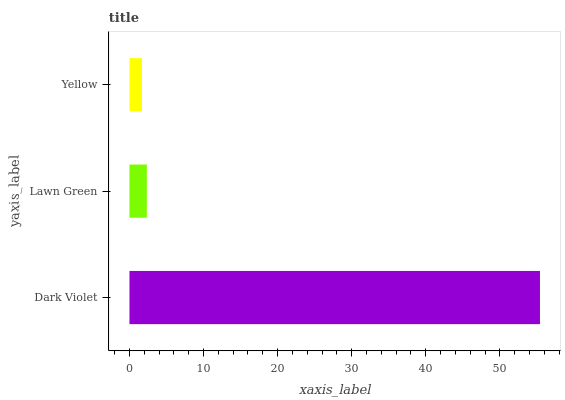Is Yellow the minimum?
Answer yes or no. Yes. Is Dark Violet the maximum?
Answer yes or no. Yes. Is Lawn Green the minimum?
Answer yes or no. No. Is Lawn Green the maximum?
Answer yes or no. No. Is Dark Violet greater than Lawn Green?
Answer yes or no. Yes. Is Lawn Green less than Dark Violet?
Answer yes or no. Yes. Is Lawn Green greater than Dark Violet?
Answer yes or no. No. Is Dark Violet less than Lawn Green?
Answer yes or no. No. Is Lawn Green the high median?
Answer yes or no. Yes. Is Lawn Green the low median?
Answer yes or no. Yes. Is Dark Violet the high median?
Answer yes or no. No. Is Dark Violet the low median?
Answer yes or no. No. 